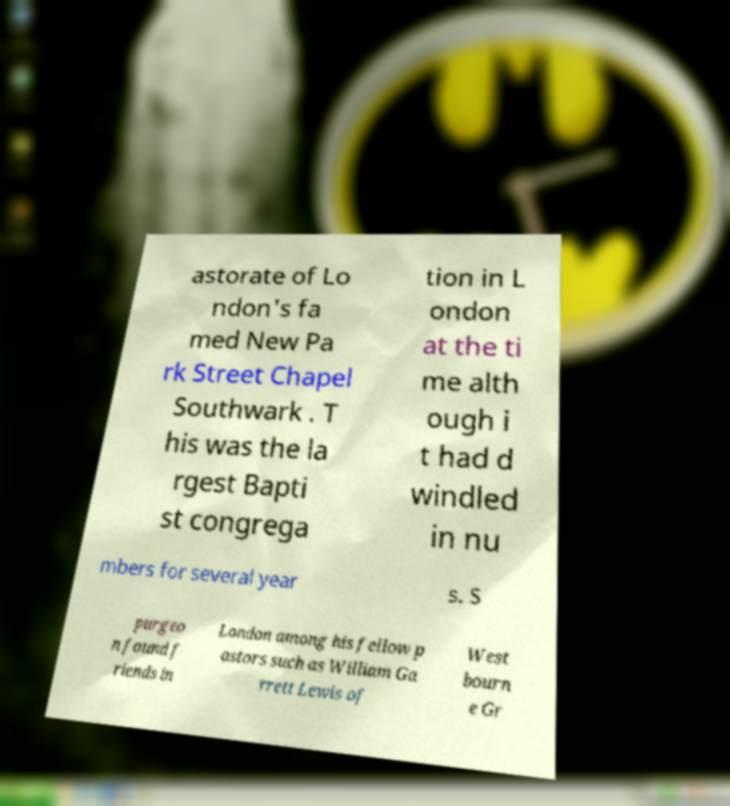Please read and relay the text visible in this image. What does it say? astorate of Lo ndon's fa med New Pa rk Street Chapel Southwark . T his was the la rgest Bapti st congrega tion in L ondon at the ti me alth ough i t had d windled in nu mbers for several year s. S purgeo n found f riends in London among his fellow p astors such as William Ga rrett Lewis of West bourn e Gr 